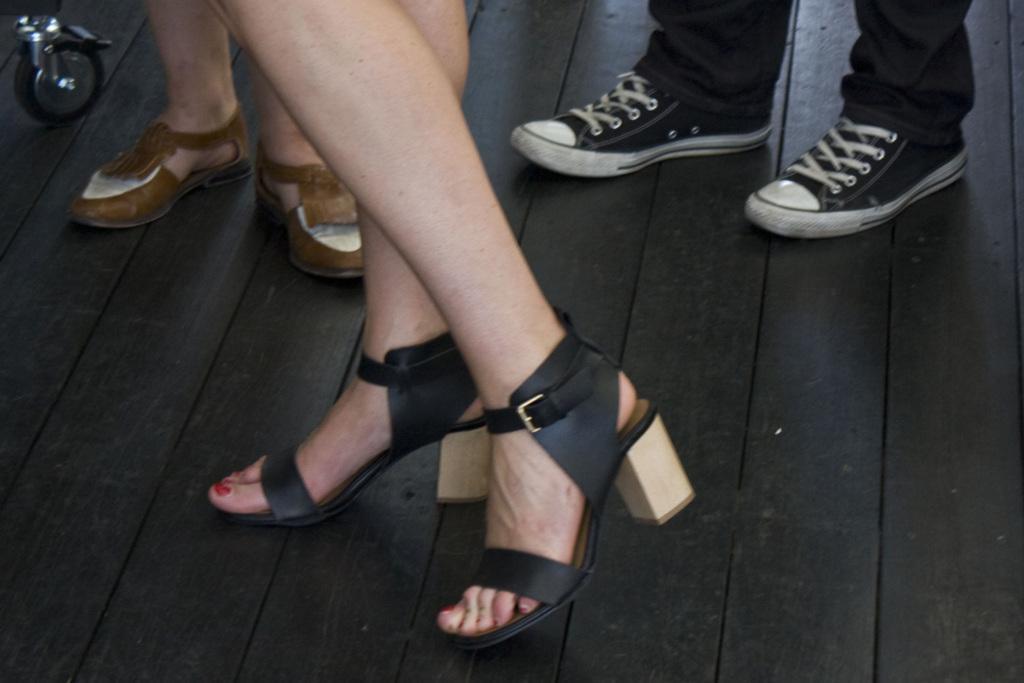How would you summarize this image in a sentence or two? We can see people legs with footwear on the wooden floor and we can see wheel. 